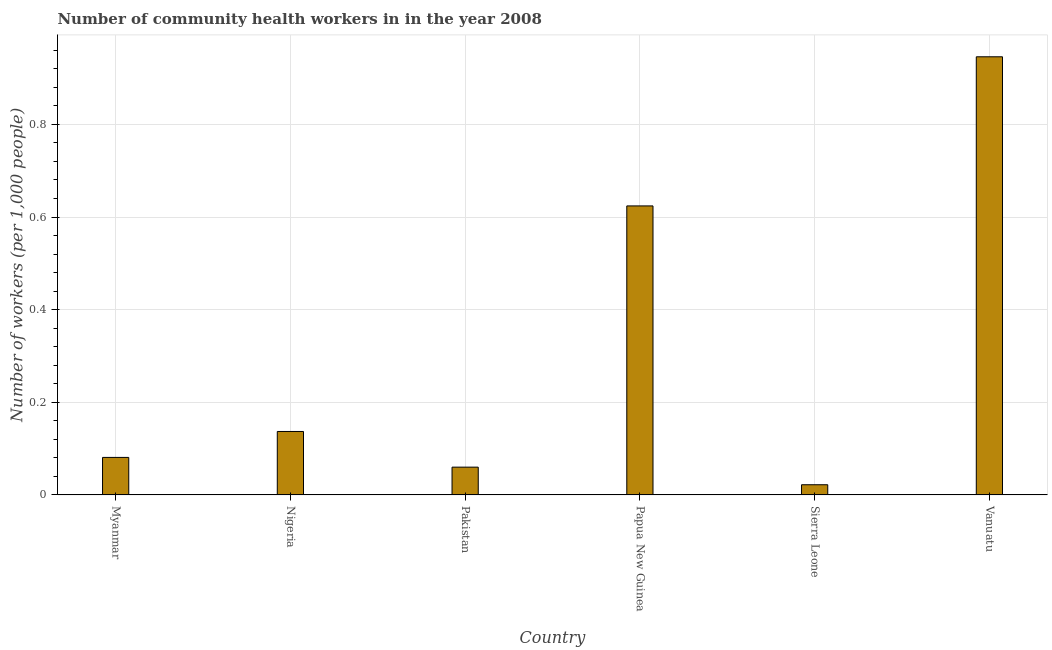Does the graph contain any zero values?
Keep it short and to the point. No. What is the title of the graph?
Your response must be concise. Number of community health workers in in the year 2008. What is the label or title of the X-axis?
Your answer should be compact. Country. What is the label or title of the Y-axis?
Ensure brevity in your answer.  Number of workers (per 1,0 people). What is the number of community health workers in Vanuatu?
Offer a very short reply. 0.95. Across all countries, what is the maximum number of community health workers?
Ensure brevity in your answer.  0.95. Across all countries, what is the minimum number of community health workers?
Ensure brevity in your answer.  0.02. In which country was the number of community health workers maximum?
Give a very brief answer. Vanuatu. In which country was the number of community health workers minimum?
Provide a succinct answer. Sierra Leone. What is the sum of the number of community health workers?
Your answer should be very brief. 1.87. What is the difference between the number of community health workers in Pakistan and Vanuatu?
Your answer should be very brief. -0.89. What is the average number of community health workers per country?
Offer a very short reply. 0.31. What is the median number of community health workers?
Provide a short and direct response. 0.11. What is the ratio of the number of community health workers in Pakistan to that in Papua New Guinea?
Provide a succinct answer. 0.1. Is the number of community health workers in Nigeria less than that in Pakistan?
Your response must be concise. No. What is the difference between the highest and the second highest number of community health workers?
Ensure brevity in your answer.  0.32. Is the sum of the number of community health workers in Myanmar and Nigeria greater than the maximum number of community health workers across all countries?
Give a very brief answer. No. What is the difference between the highest and the lowest number of community health workers?
Make the answer very short. 0.92. In how many countries, is the number of community health workers greater than the average number of community health workers taken over all countries?
Ensure brevity in your answer.  2. How many bars are there?
Your answer should be compact. 6. Are all the bars in the graph horizontal?
Provide a short and direct response. No. How many countries are there in the graph?
Keep it short and to the point. 6. What is the difference between two consecutive major ticks on the Y-axis?
Your answer should be very brief. 0.2. Are the values on the major ticks of Y-axis written in scientific E-notation?
Provide a short and direct response. No. What is the Number of workers (per 1,000 people) in Myanmar?
Your answer should be very brief. 0.08. What is the Number of workers (per 1,000 people) in Nigeria?
Give a very brief answer. 0.14. What is the Number of workers (per 1,000 people) of Pakistan?
Make the answer very short. 0.06. What is the Number of workers (per 1,000 people) of Papua New Guinea?
Offer a terse response. 0.62. What is the Number of workers (per 1,000 people) of Sierra Leone?
Ensure brevity in your answer.  0.02. What is the Number of workers (per 1,000 people) of Vanuatu?
Offer a very short reply. 0.95. What is the difference between the Number of workers (per 1,000 people) in Myanmar and Nigeria?
Offer a terse response. -0.06. What is the difference between the Number of workers (per 1,000 people) in Myanmar and Pakistan?
Make the answer very short. 0.02. What is the difference between the Number of workers (per 1,000 people) in Myanmar and Papua New Guinea?
Your answer should be compact. -0.54. What is the difference between the Number of workers (per 1,000 people) in Myanmar and Sierra Leone?
Provide a short and direct response. 0.06. What is the difference between the Number of workers (per 1,000 people) in Myanmar and Vanuatu?
Make the answer very short. -0.86. What is the difference between the Number of workers (per 1,000 people) in Nigeria and Pakistan?
Keep it short and to the point. 0.08. What is the difference between the Number of workers (per 1,000 people) in Nigeria and Papua New Guinea?
Ensure brevity in your answer.  -0.49. What is the difference between the Number of workers (per 1,000 people) in Nigeria and Sierra Leone?
Provide a short and direct response. 0.12. What is the difference between the Number of workers (per 1,000 people) in Nigeria and Vanuatu?
Offer a terse response. -0.81. What is the difference between the Number of workers (per 1,000 people) in Pakistan and Papua New Guinea?
Give a very brief answer. -0.56. What is the difference between the Number of workers (per 1,000 people) in Pakistan and Sierra Leone?
Make the answer very short. 0.04. What is the difference between the Number of workers (per 1,000 people) in Pakistan and Vanuatu?
Provide a succinct answer. -0.89. What is the difference between the Number of workers (per 1,000 people) in Papua New Guinea and Sierra Leone?
Provide a succinct answer. 0.6. What is the difference between the Number of workers (per 1,000 people) in Papua New Guinea and Vanuatu?
Provide a short and direct response. -0.32. What is the difference between the Number of workers (per 1,000 people) in Sierra Leone and Vanuatu?
Your answer should be compact. -0.92. What is the ratio of the Number of workers (per 1,000 people) in Myanmar to that in Nigeria?
Provide a short and direct response. 0.59. What is the ratio of the Number of workers (per 1,000 people) in Myanmar to that in Pakistan?
Your response must be concise. 1.35. What is the ratio of the Number of workers (per 1,000 people) in Myanmar to that in Papua New Guinea?
Keep it short and to the point. 0.13. What is the ratio of the Number of workers (per 1,000 people) in Myanmar to that in Sierra Leone?
Offer a terse response. 3.68. What is the ratio of the Number of workers (per 1,000 people) in Myanmar to that in Vanuatu?
Your answer should be compact. 0.09. What is the ratio of the Number of workers (per 1,000 people) in Nigeria to that in Pakistan?
Keep it short and to the point. 2.28. What is the ratio of the Number of workers (per 1,000 people) in Nigeria to that in Papua New Guinea?
Ensure brevity in your answer.  0.22. What is the ratio of the Number of workers (per 1,000 people) in Nigeria to that in Sierra Leone?
Offer a terse response. 6.23. What is the ratio of the Number of workers (per 1,000 people) in Nigeria to that in Vanuatu?
Make the answer very short. 0.14. What is the ratio of the Number of workers (per 1,000 people) in Pakistan to that in Papua New Guinea?
Your answer should be compact. 0.1. What is the ratio of the Number of workers (per 1,000 people) in Pakistan to that in Sierra Leone?
Offer a very short reply. 2.73. What is the ratio of the Number of workers (per 1,000 people) in Pakistan to that in Vanuatu?
Offer a terse response. 0.06. What is the ratio of the Number of workers (per 1,000 people) in Papua New Guinea to that in Sierra Leone?
Provide a short and direct response. 28.36. What is the ratio of the Number of workers (per 1,000 people) in Papua New Guinea to that in Vanuatu?
Your answer should be compact. 0.66. What is the ratio of the Number of workers (per 1,000 people) in Sierra Leone to that in Vanuatu?
Keep it short and to the point. 0.02. 